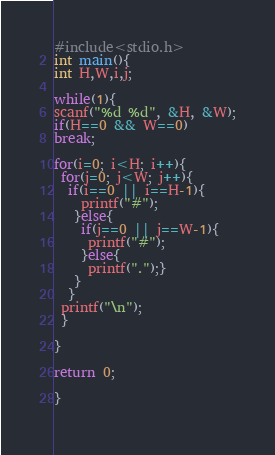<code> <loc_0><loc_0><loc_500><loc_500><_C_>#include<stdio.h>
int main(){
int H,W,i,j;

while(1){
scanf("%d %d", &H, &W);
if(H==0 && W==0)
break;

for(i=0; i<H; i++){
 for(j=0; j<W; j++){
  if(i==0 || i==H-1){
    printf("#");
   }else{
    if(j==0 || j==W-1){
     printf("#");
    }else{
     printf(".");}
   }
  }
 printf("\n");
 }

}

return 0;

}
  </code> 